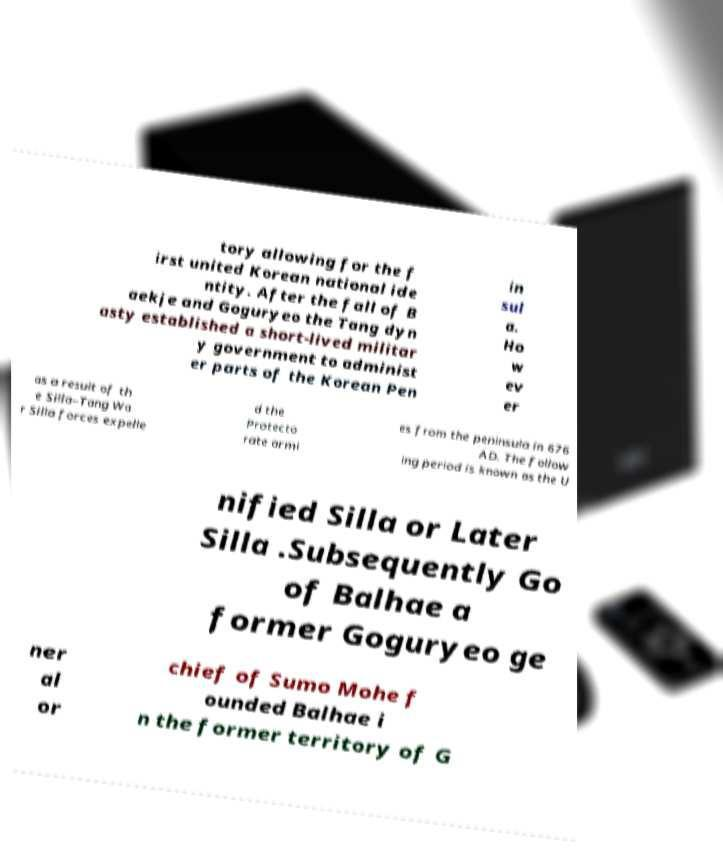Can you read and provide the text displayed in the image?This photo seems to have some interesting text. Can you extract and type it out for me? tory allowing for the f irst united Korean national ide ntity. After the fall of B aekje and Goguryeo the Tang dyn asty established a short-lived militar y government to administ er parts of the Korean Pen in sul a. Ho w ev er as a result of th e Silla–Tang Wa r Silla forces expelle d the Protecto rate armi es from the peninsula in 676 AD. The follow ing period is known as the U nified Silla or Later Silla .Subsequently Go of Balhae a former Goguryeo ge ner al or chief of Sumo Mohe f ounded Balhae i n the former territory of G 